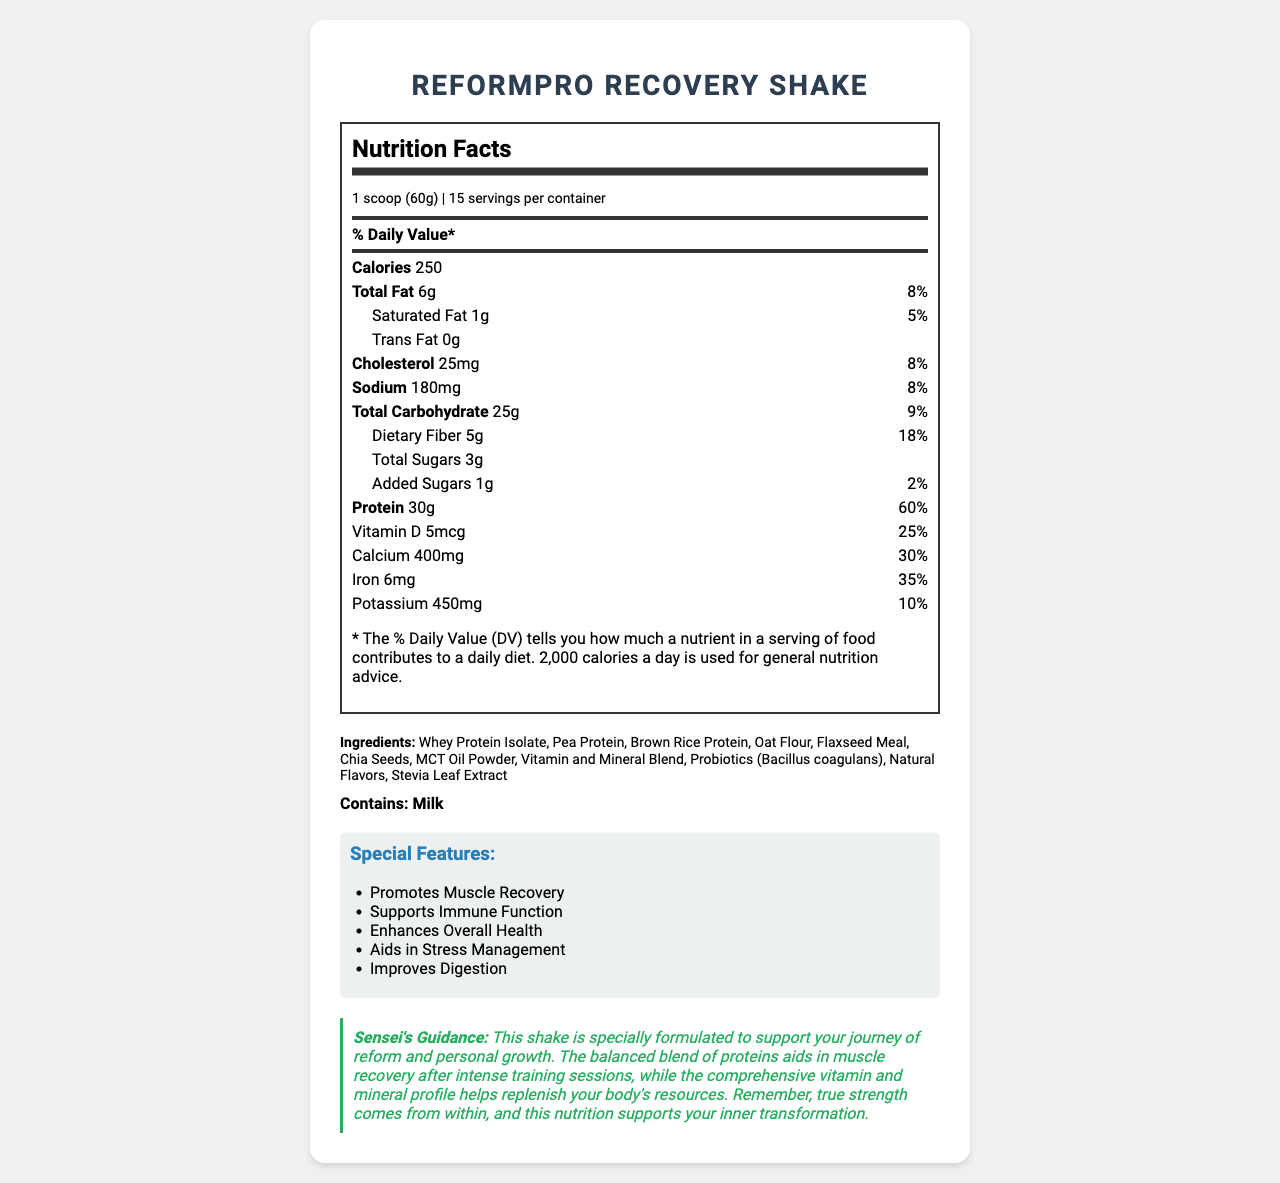what is the serving size? The serving size is explicitly mentioned at the beginning of the Nutrition Facts section.
Answer: 1 scoop (60g) how many servings are there per container? This information is provided under the serving size in the Nutrition Facts section.
Answer: 15 what is the total fat content per serving? The total fat amount is listed directly under the Nutrition Facts with the value "6g".
Answer: 6g how many grams of dietary fiber are in each serving? The dietary fiber content is mentioned under the Total Carbohydrate section with the value "5g".
Answer: 5g what percentage of the Daily Value for protein does the shake provide per serving? The Daily Value for protein is given as 60% in the Nutrition Facts section.
Answer: 60% what are the main ingredients of the ReformPro Recovery Shake? These ingredients are listed under the "Ingredients" section of the document.
Answer: Whey Protein Isolate, Pea Protein, Brown Rice Protein, Oat Flour, Flaxseed Meal, Chia Seeds, MCT Oil Powder, Vitamin and Mineral Blend, Probiotics (Bacillus coagulans), Natural Flavors, Stevia Leaf Extract identify the allergen present in the shake. A. Soy B. Milk C. Wheat D. Nuts The allergen information section clearly says "Contains: Milk".
Answer: B how many calories are there per serving? A. 100 B. 150 C. 200 D. 250 The total calories per serving are given as 250 in the Nutrition Facts section.
Answer: D does this shake contain any trans fat? The Nutrition Facts explicitly state "Trans Fat 0g".
Answer: No summarize the primary focus of the ReformPro Recovery Shake's nutrition facts. The summary includes the shake's primary elements, such as calorie content, macronutrients, and vitamins/minerals, focusing on its role in muscle recovery and health improvement.
Answer: The ReformPro Recovery Shake provides comprehensive nutrition facts optimized for muscle recovery and overall health improvement. Each serving contains 250 calories, 6g total fat, 25g total carbohydrates (including 5g dietary fiber), and 30g protein. It also includes a wide range of vitamins and minerals to support various bodily functions. what is the sensei's guidance regarding using this product? The sensei's guidance is provided in the "Sensei's Guidance" section.
Answer: This shake is specially formulated to support your journey of reform and personal growth. It aids muscle recovery, replenishes resources, and supports inner transformation. what is the amount of added sugars per serving? The amount of added sugars is listed in the Nutrition Facts section under Total Carbohydrates.
Answer: 1g what is the daily value percentage provided by the amount of selenium in the shake? The daily value percentage for selenium is given in the Nutrition Facts section as 64%.
Answer: 64% does the shake enhance digestion? According to the "Special Features" section, one of the features is "Improves Digestion."
Answer: Yes how much potassium does one serving contain? The amount of potassium per serving is listed under the Nutrition Facts section as 450mg.
Answer: 450mg are probiotics included in this shake? The ingredient list includes "Probiotics (Bacillus coagulans)."
Answer: Yes how effective is the shake in supporting immune function? A. Not at all B. Somewhat effective C. Highly effective D. Not enough information to determine According to the "Special Features" section, the shake "Supports Immune Function," indicating it is highly effective.
Answer: C does this product include the percentage of daily value for Vitamin K? The Nutrition Facts provide the percentage of daily value for Vitamin K, which is 50%.
Answer: Yes which ingredient in the list potentially contains allergens? According to the allergen section, the product contains milk, and whey protein isolate is derived from milk.
Answer: Whey Protein Isolate can the exact proportion of each vitamin and mineral blend be determined from the document? The document does not provide detailed proportions of each component in the vitamin and mineral blend, only the amounts of some key vitamins and minerals.
Answer: No 